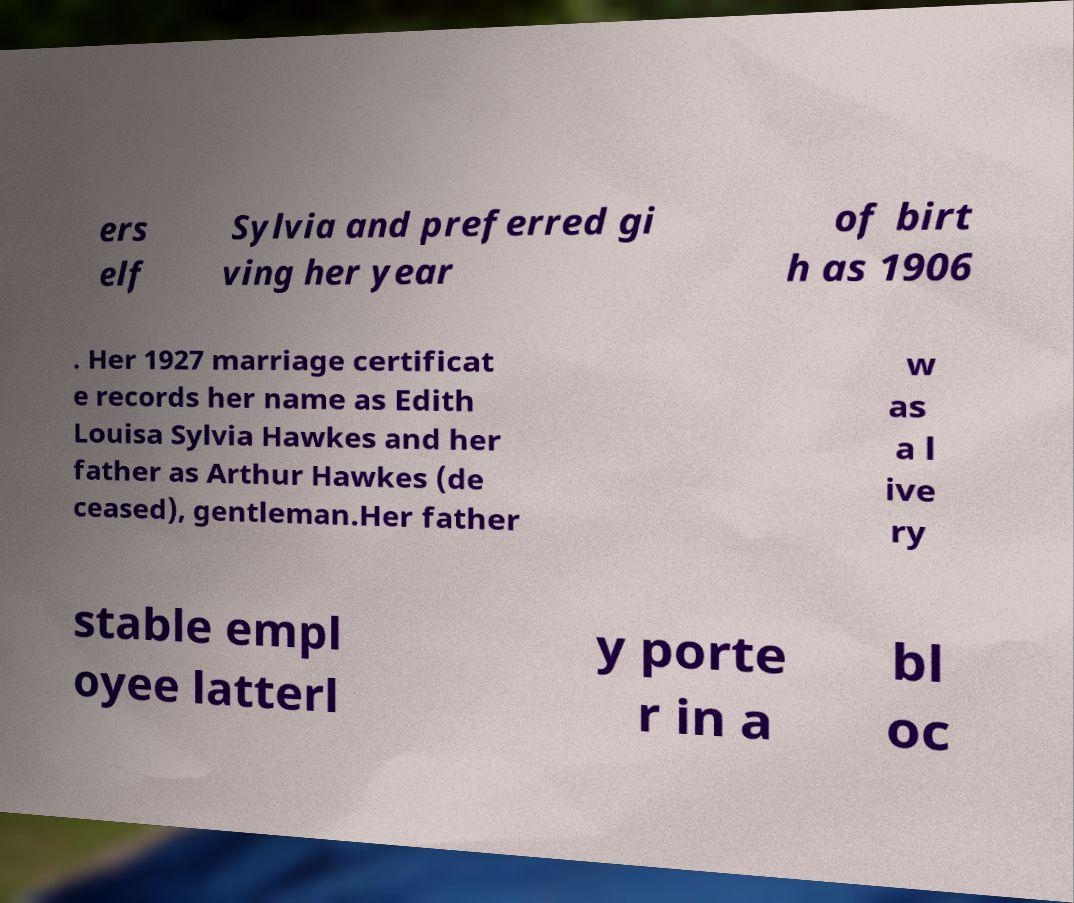What messages or text are displayed in this image? I need them in a readable, typed format. ers elf Sylvia and preferred gi ving her year of birt h as 1906 . Her 1927 marriage certificat e records her name as Edith Louisa Sylvia Hawkes and her father as Arthur Hawkes (de ceased), gentleman.Her father w as a l ive ry stable empl oyee latterl y porte r in a bl oc 